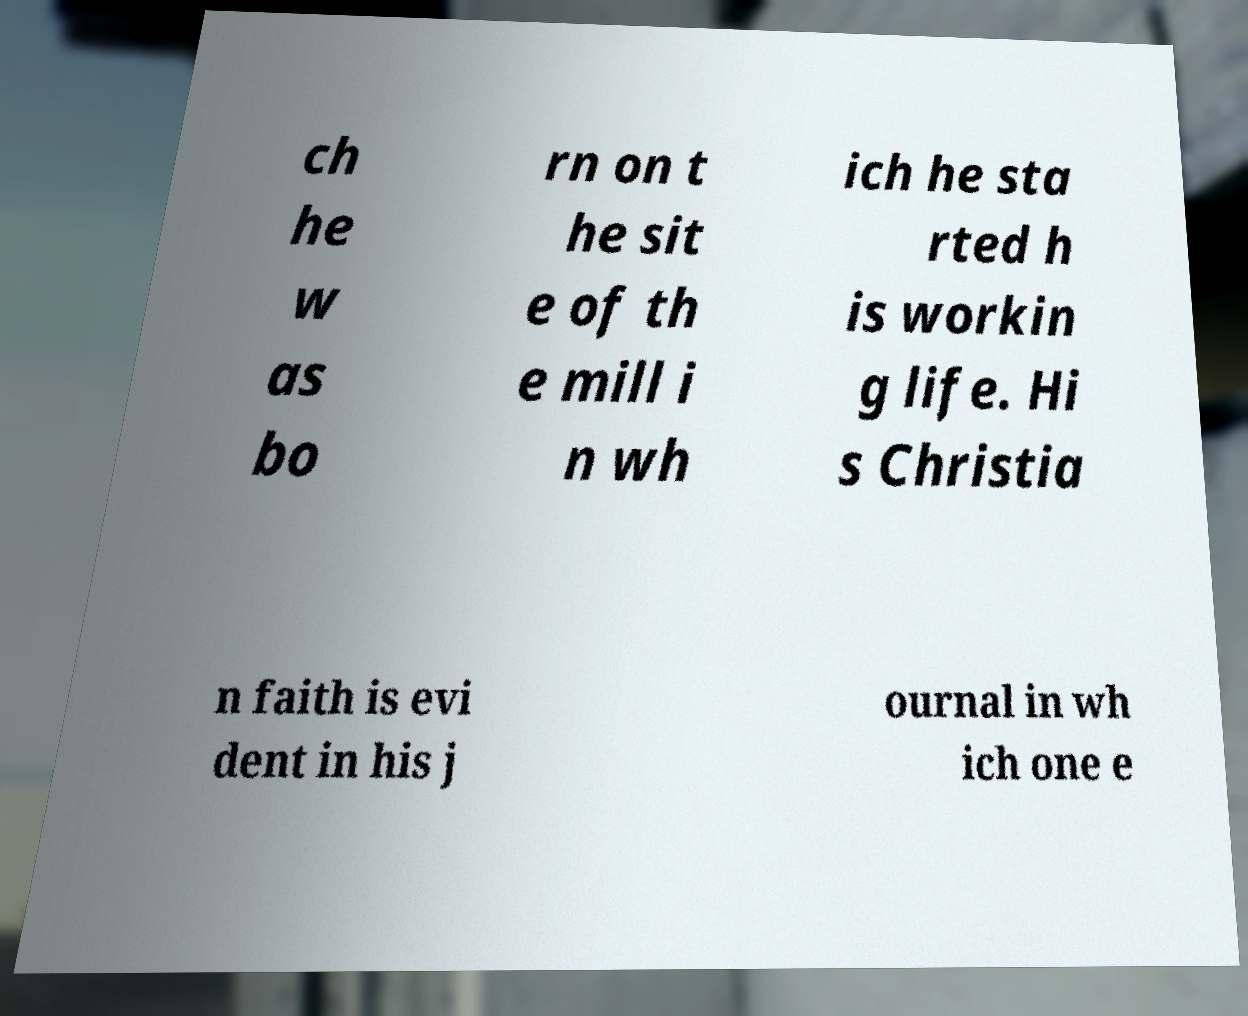I need the written content from this picture converted into text. Can you do that? ch he w as bo rn on t he sit e of th e mill i n wh ich he sta rted h is workin g life. Hi s Christia n faith is evi dent in his j ournal in wh ich one e 